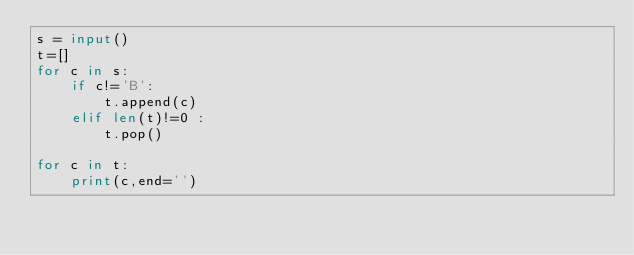Convert code to text. <code><loc_0><loc_0><loc_500><loc_500><_Python_>s = input()
t=[]
for c in s:
    if c!='B':
        t.append(c)
    elif len(t)!=0 :
        t.pop()

for c in t:
    print(c,end='')
</code> 